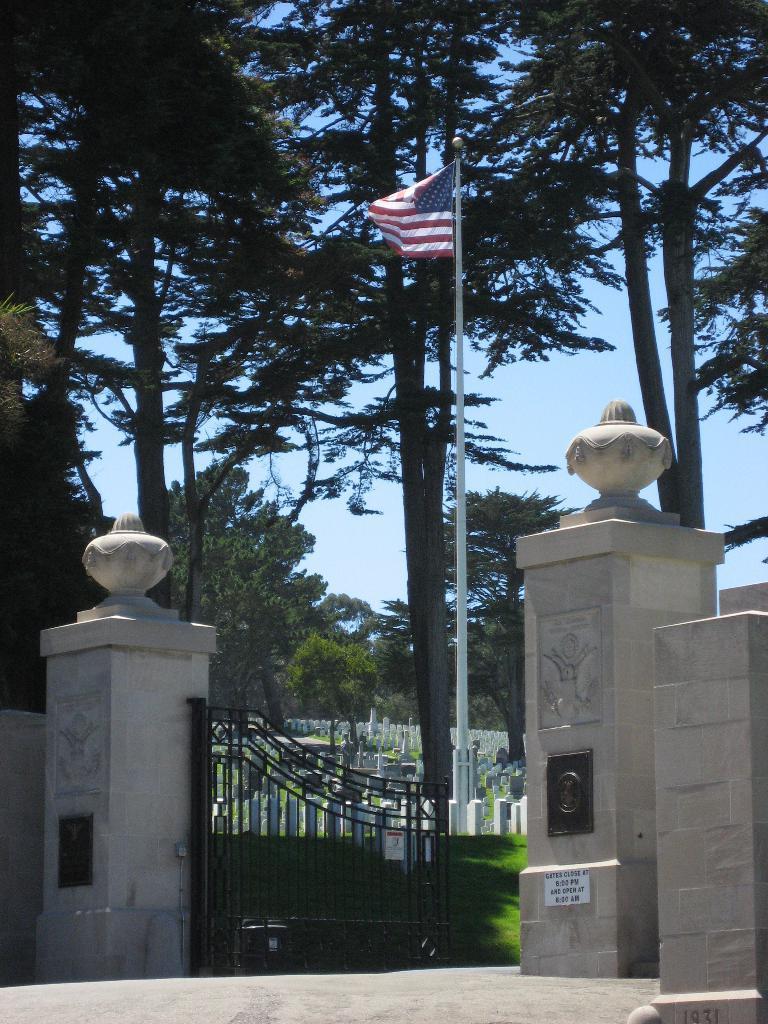Could you give a brief overview of what you see in this image? In this image there are pillars, wall, gate, flag and few objects on the surface of the grass, trees and the sky. 